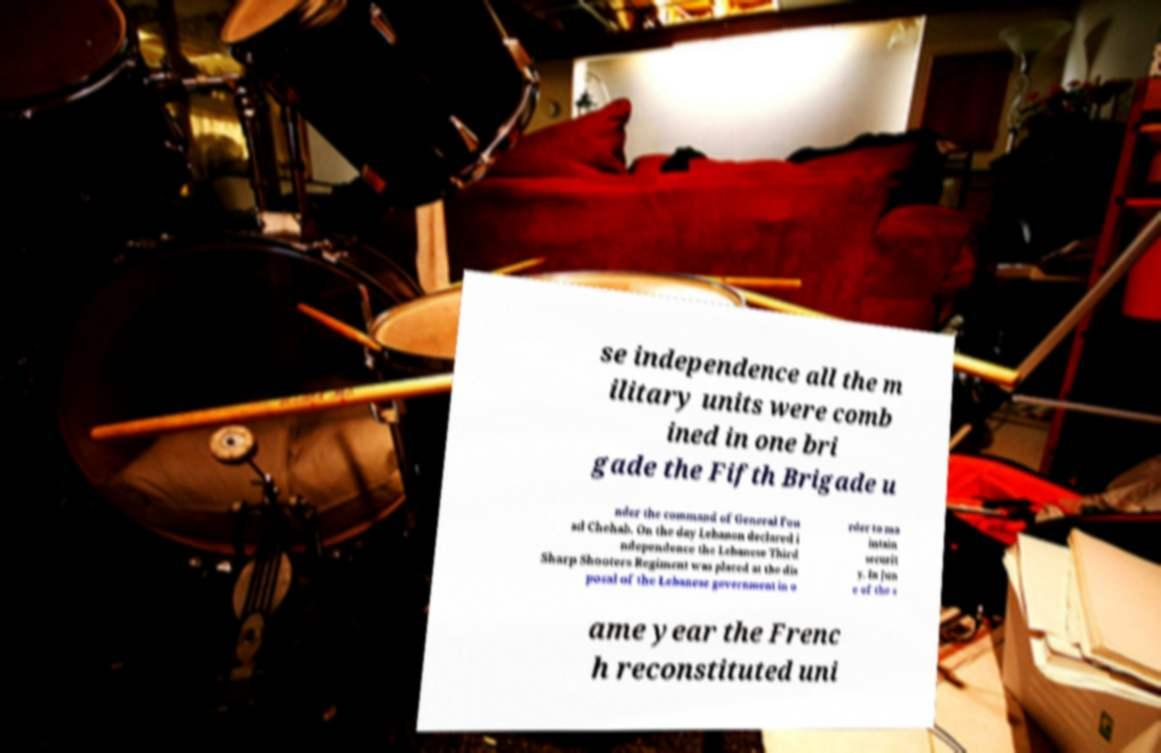There's text embedded in this image that I need extracted. Can you transcribe it verbatim? se independence all the m ilitary units were comb ined in one bri gade the Fifth Brigade u nder the command of General Fou ad Chehab. On the day Lebanon declared i ndependence the Lebanese Third Sharp Shooters Regiment was placed at the dis posal of the Lebanese government in o rder to ma intain securit y. In Jun e of the s ame year the Frenc h reconstituted uni 